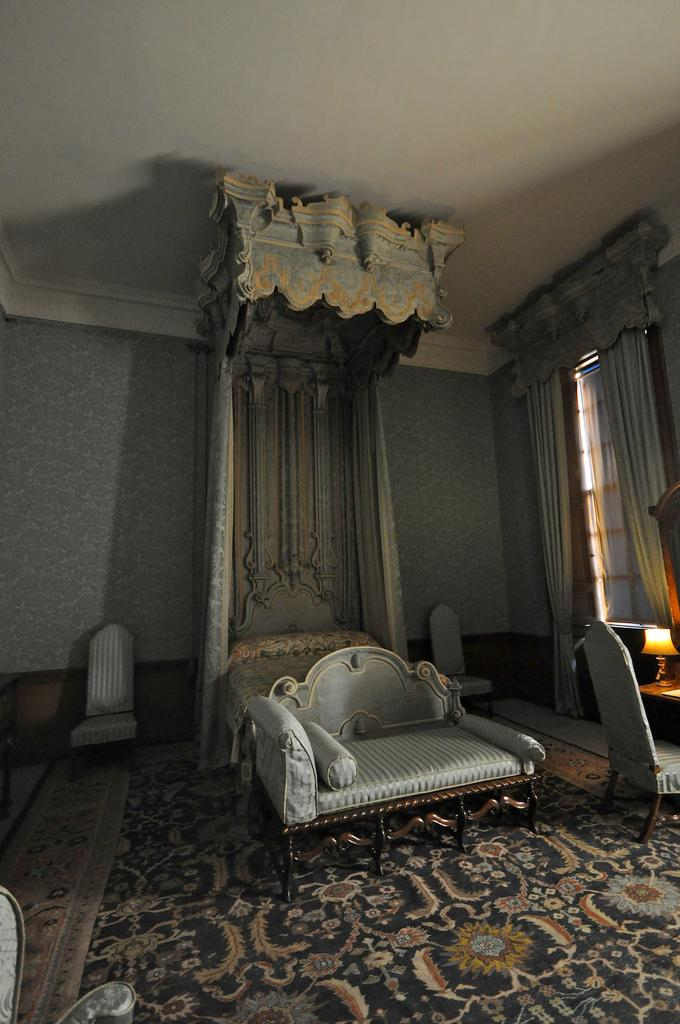What type of space is shown in the image? The image depicts a room. What furniture is present in the room? There is a sofa, chairs, and a table in the room. What is on the table in the room? There is a lamp on the table. What can be seen in the background of the room? There are curtains and windows in the background. What type of agreement is being signed on the bed in the image? There is no bed present in the image, and therefore no agreement being signed. How many wheels can be seen on the furniture in the image? There are no wheels visible on the furniture in the image. 